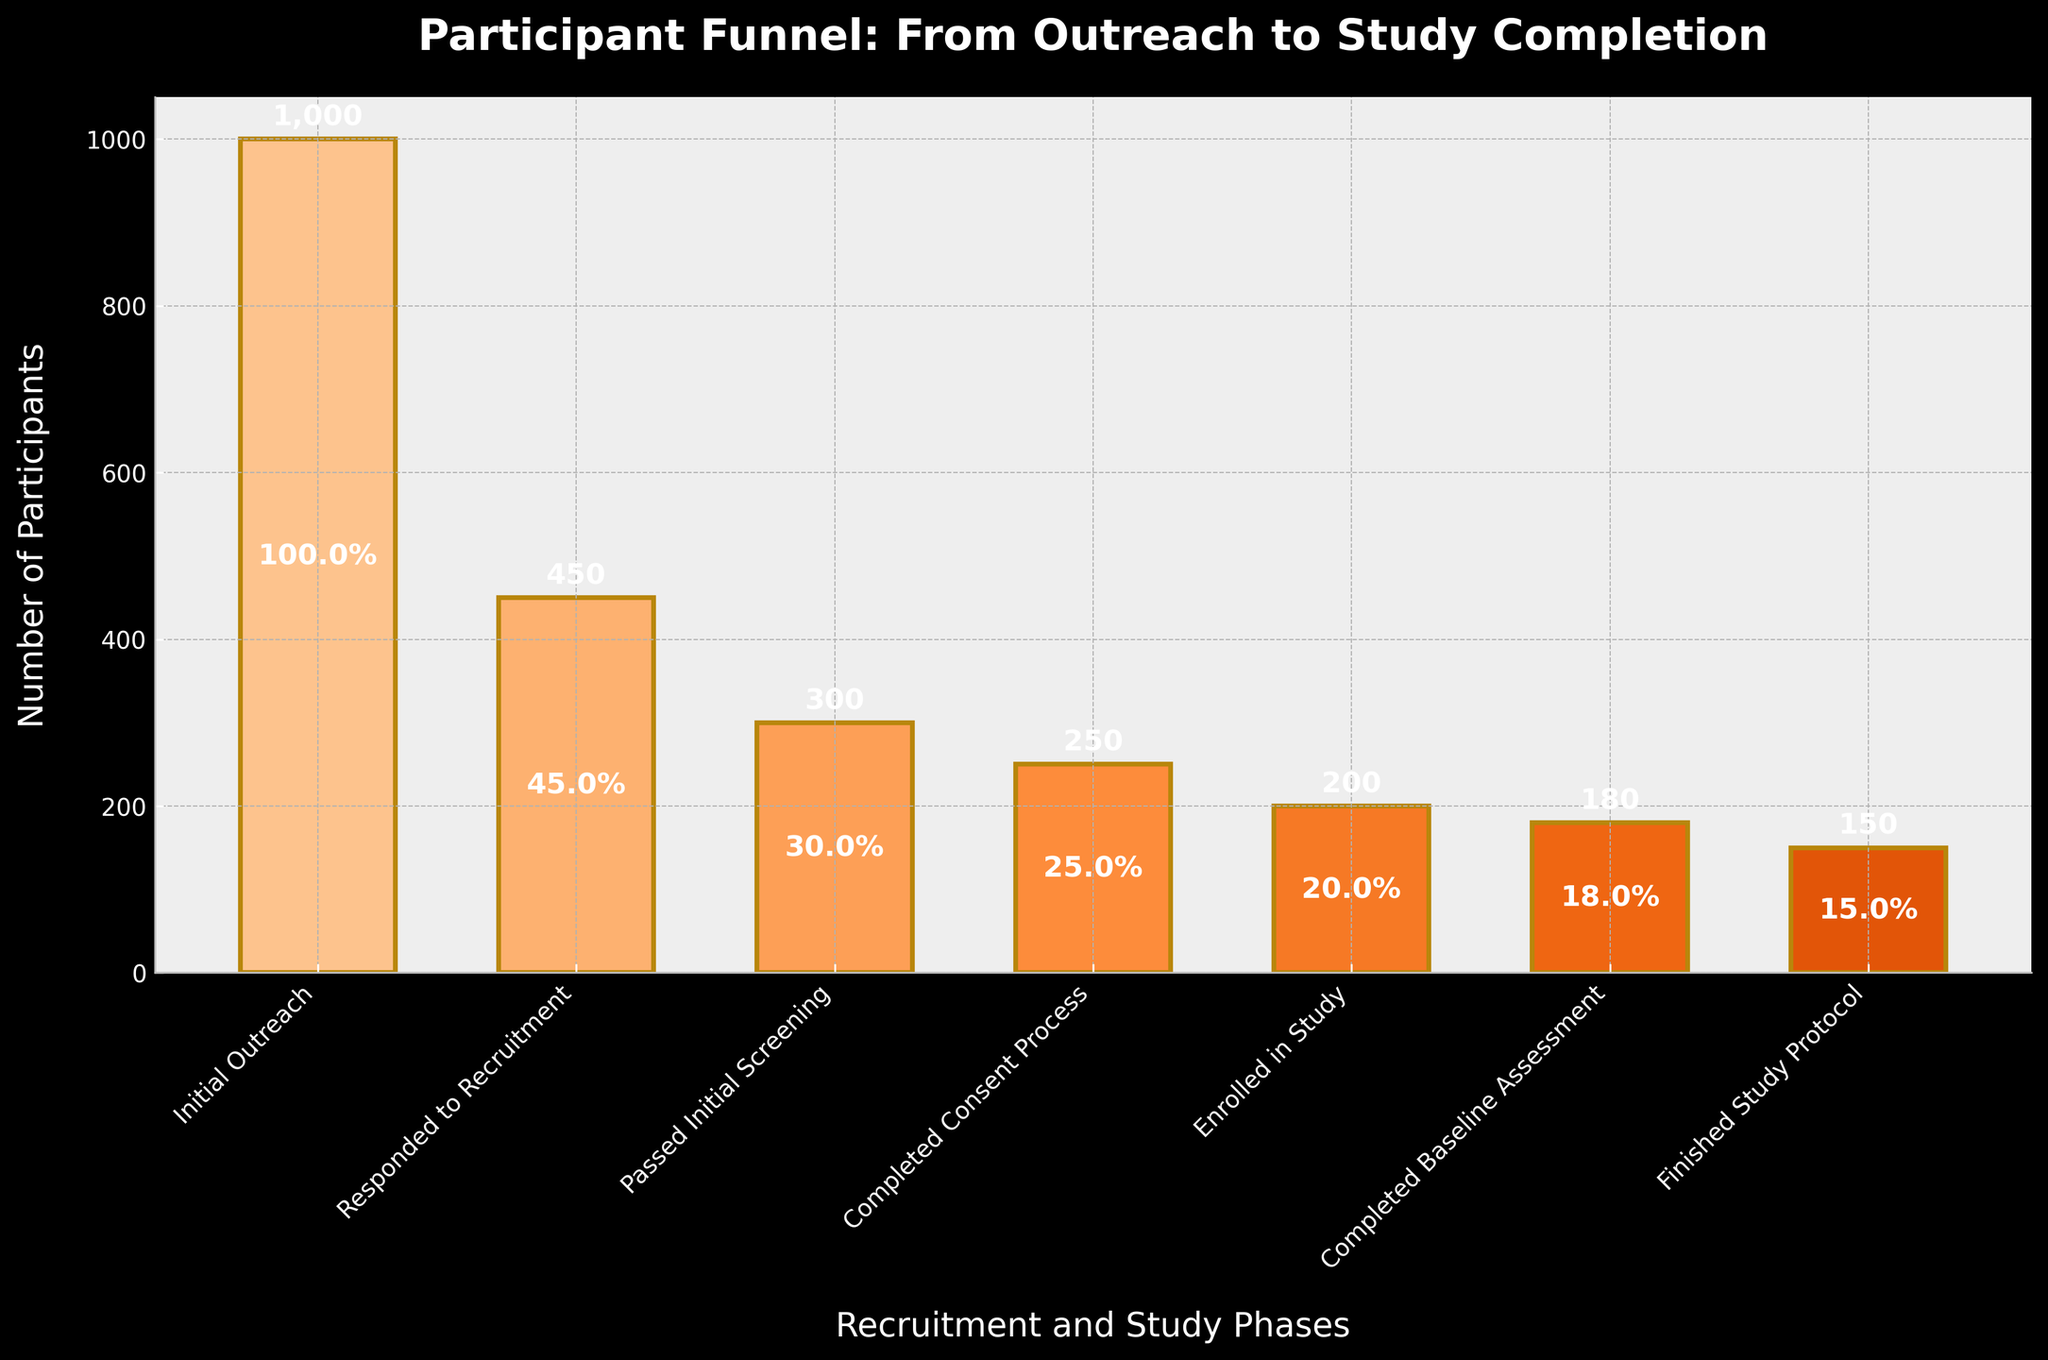How many participants responded to the recruitment? Look at the bar labeled "Responded to Recruitment" and read the number of participants directly from the figure.
Answer: 450 What's the percentage decrease in participants from "Completed Consent Process" to "Enrolled in Study"? First, identify the number of participants in each phase ("Completed Consent Process" = 250 and "Enrolled in Study" = 200). Calculate the decrease (250 - 200 = 50). Then, calculate the percentage decrease: (50/250) * 100 = 20%.
Answer: 20% Between which two phases is the largest drop in the number of participants? Compare the number of participants in adjacent phases and identify the largest difference. The phases are: "Initial Outreach" to "Responded to Recruitment" (1000 - 450 = 550), "Responded to Recruitment" to "Passed Initial Screening" (450 - 300 = 150), etc. The largest drop is between "Initial Outreach" and "Responded to Recruitment" with a difference of 550.
Answer: Initial Outreach to Responded to Recruitment What is the ratio of participants who finished the study protocol to those who enrolled in the study? Identify the number of participants who finished the study protocol (150) and those who enrolled in the study (200). Calculate the ratio: 150/200 = 0.75.
Answer: 0.75 Which recruitment and study phase has the least number of participants? Look at all the phases and their corresponding participant numbers. Identify the smallest number, which is for the "Finished Study Protocol" phase with 150 participants.
Answer: Finished Study Protocol How many participants did not complete the consent process after passing the initial screening? Identify the number of participants in "Passed Initial Screening" (300) and "Completed Consent Process" (250). Subtract to find those who did not complete: 300 - 250 = 50.
Answer: 50 If 10 more participants had finished the study protocol, what would the new completion percentage of this phase be as compared to the initial outreach? The initial number for "Finished Study Protocol" is 150. Adding 10 more makes it 160. The completion percentage is (160/1000) * 100 = 16%.
Answer: 16% How many participants completed at least the baseline assessment phase? The number of participants who completed up to the "Baseline Assessment" phase is 180.
Answer: 180 By how many participants does the "Initial Outreach" phase exceed the "Passed Initial Screening" phase? Identify the numbers of participants in the "Initial Outreach" (1000) and "Passed Initial Screening" (300) phases. Subtract to find the difference: 1000 - 300 = 700.
Answer: 700 